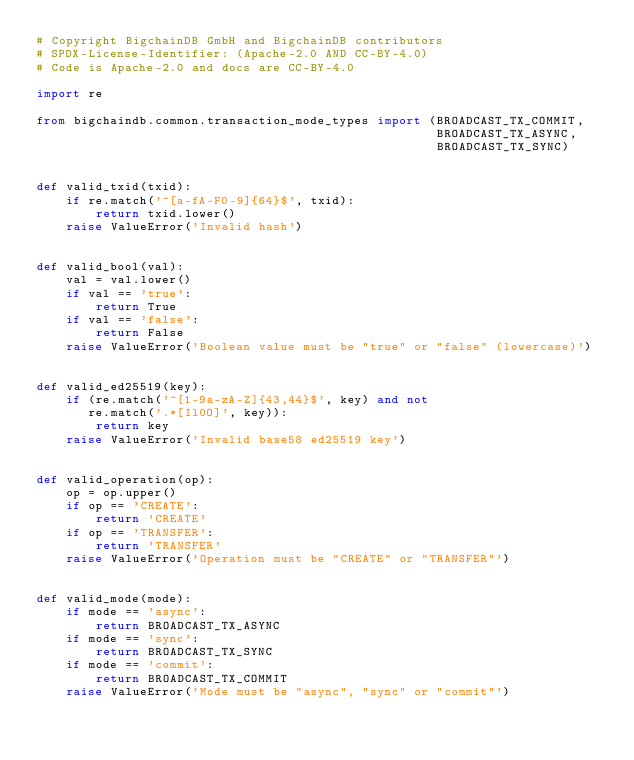Convert code to text. <code><loc_0><loc_0><loc_500><loc_500><_Python_># Copyright BigchainDB GmbH and BigchainDB contributors
# SPDX-License-Identifier: (Apache-2.0 AND CC-BY-4.0)
# Code is Apache-2.0 and docs are CC-BY-4.0

import re

from bigchaindb.common.transaction_mode_types import (BROADCAST_TX_COMMIT,
                                                      BROADCAST_TX_ASYNC,
                                                      BROADCAST_TX_SYNC)


def valid_txid(txid):
    if re.match('^[a-fA-F0-9]{64}$', txid):
        return txid.lower()
    raise ValueError('Invalid hash')


def valid_bool(val):
    val = val.lower()
    if val == 'true':
        return True
    if val == 'false':
        return False
    raise ValueError('Boolean value must be "true" or "false" (lowercase)')


def valid_ed25519(key):
    if (re.match('^[1-9a-zA-Z]{43,44}$', key) and not
       re.match('.*[Il0O]', key)):
        return key
    raise ValueError('Invalid base58 ed25519 key')


def valid_operation(op):
    op = op.upper()
    if op == 'CREATE':
        return 'CREATE'
    if op == 'TRANSFER':
        return 'TRANSFER'
    raise ValueError('Operation must be "CREATE" or "TRANSFER"')


def valid_mode(mode):
    if mode == 'async':
        return BROADCAST_TX_ASYNC
    if mode == 'sync':
        return BROADCAST_TX_SYNC
    if mode == 'commit':
        return BROADCAST_TX_COMMIT
    raise ValueError('Mode must be "async", "sync" or "commit"')
</code> 